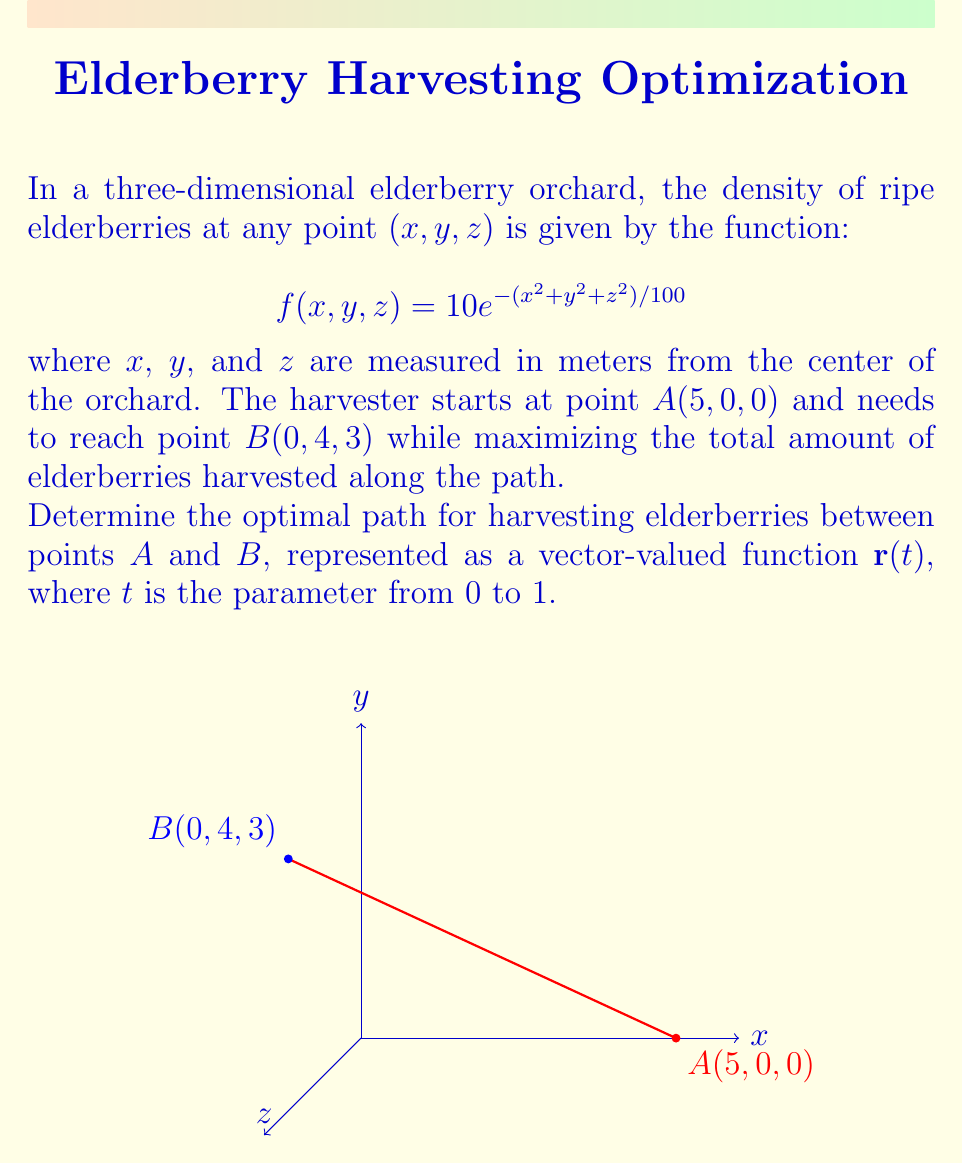Help me with this question. To find the optimal path, we need to maximize the line integral of the density function along the path from A to B. The optimal path will follow the direction of the gradient of the density function.

Step 1: Calculate the gradient of f(x,y,z).
$$\nabla f = \left(-\frac{1}{5}xe^{-(x^2+y^2+z^2)/100}, -\frac{1}{5}ye^{-(x^2+y^2+z^2)/100}, -\frac{1}{5}ze^{-(x^2+y^2+z^2)/100}\right)$$

Step 2: Set up the differential equation for the optimal path.
$$\frac{d\mathbf{r}}{dt} = \nabla f(\mathbf{r})$$

Step 3: Solve the differential equation.
Due to the symmetry of the density function, the optimal path will be a straight line from A to B. We can represent this path as:

$$\mathbf{r}(t) = (1-t)\mathbf{A} + t\mathbf{B}$$

Step 4: Express the optimal path as a vector-valued function.
$$\mathbf{r}(t) = ((1-t)5, 4t, 3t)$$

Step 5: Verify the boundary conditions.
At t = 0: $\mathbf{r}(0) = (5, 0, 0) = \mathbf{A}$
At t = 1: $\mathbf{r}(1) = (0, 4, 3) = \mathbf{B}$

Therefore, the optimal path for harvesting elderberries between points A and B is represented by the vector-valued function $\mathbf{r}(t) = (5-5t, 4t, 3t)$ for $0 \leq t \leq 1$.
Answer: $\mathbf{r}(t) = (5-5t, 4t, 3t)$, $0 \leq t \leq 1$ 